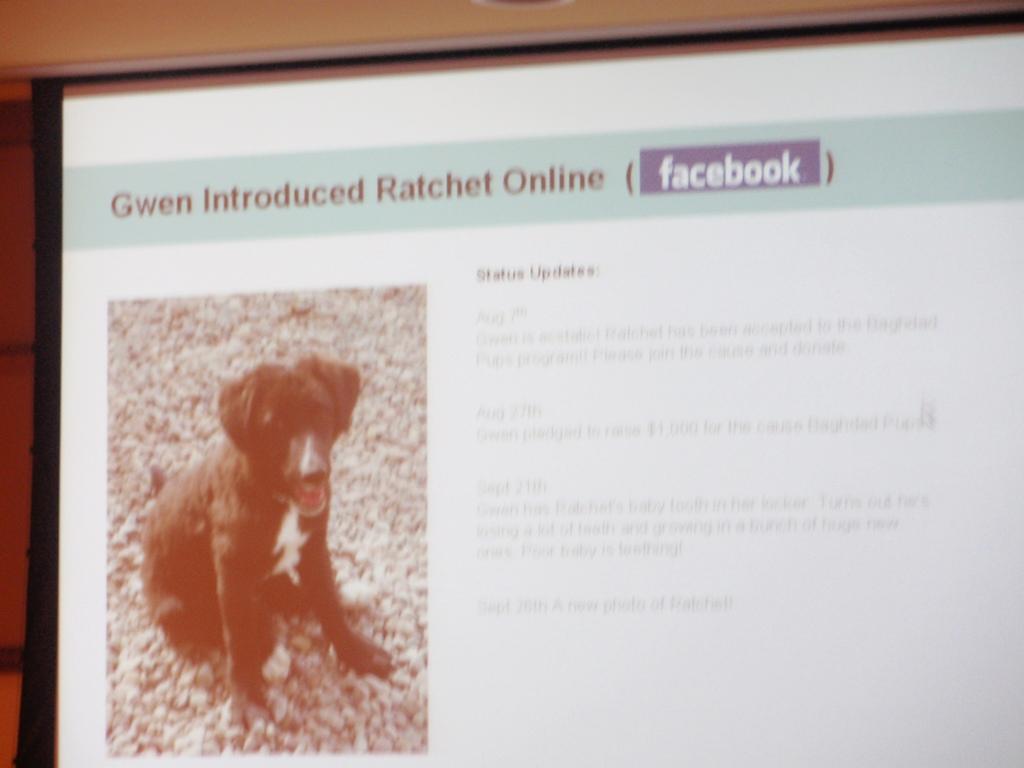Could you give a brief overview of what you see in this image? In this image, we can see a screen, on the left side of the screen, we can see the image of the dog sitting on the stone. On the right side of the screen, we can see some text, on which it is printed. In the background, we can see a wall. 